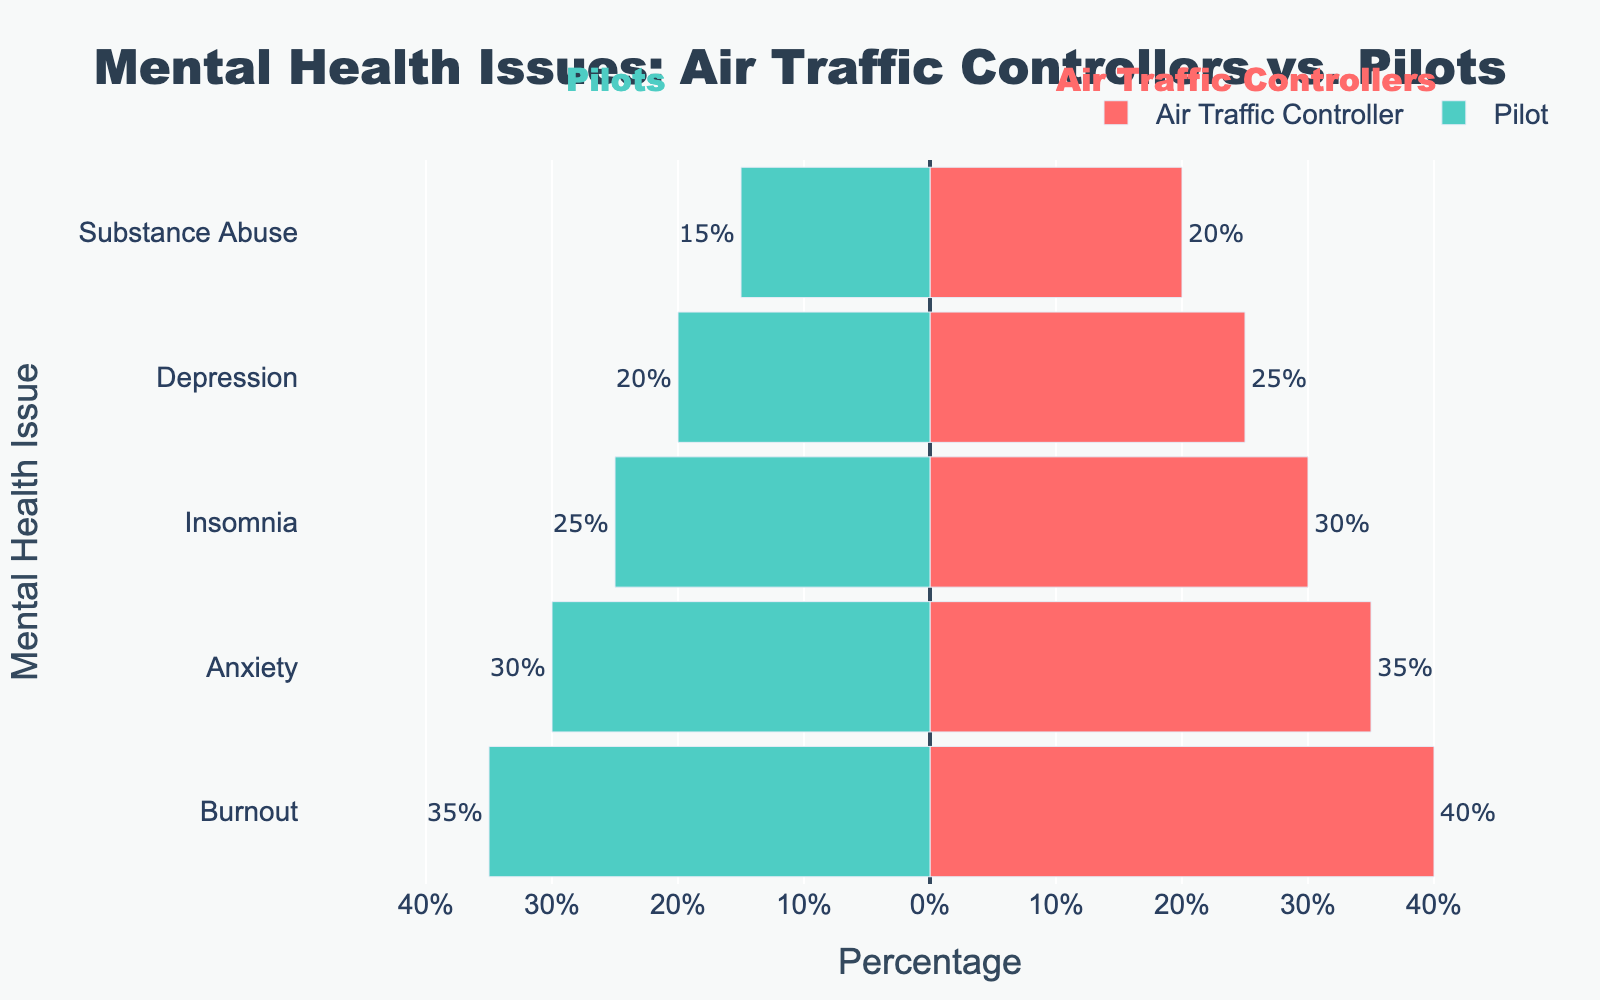Which profession has a higher percentage of anxiety issues? The bars representing anxiety indicate that Air Traffic Controllers have a 35% rate, while Pilots have a 30% rate. Therefore, Air Traffic Controllers have a higher percentage of anxiety issues.
Answer: Air Traffic Controllers What is the difference in the percentage of burnout between Air Traffic Controllers and Pilots? Air Traffic Controllers exhibit a burnout percentage of 40%, whereas Pilots have a 35% rate. Subtracting these values gives 40% - 35% = 5%.
Answer: 5% Which profession has fewer issues with substance abuse, and by what percentage? On the graph, Pilots have a 15% rate of substance abuse, while Air Traffic Controllers have a 20% rate. Subtracting these values gives 20% - 15% = 5%. Therefore, Pilots have fewer issues with substance abuse by 5%.
Answer: Pilots, 5% What is the sum of the percentages for depression and insomnia among Air Traffic Controllers? The graph shows that Air Traffic Controllers have a 25% rate for depression and a 30% rate for insomnia. Adding these values gives 25% + 30% = 55%.
Answer: 55% Which mental health issue has the largest difference in percentage between the two professions? By analyzing each mental health issue on the graph, burnout has the following percentages: Air Traffic Controllers at 40% and Pilots at 35%. This 5% difference is the largest among all the compared categories.
Answer: Burnout Among the issues affecting Air Traffic Controllers, which has the smallest percentage? By observing the lengths of the bars for Air Traffic Controllers, substance abuse has the smallest percentage at 20%.
Answer: Substance Abuse By how much does the percentage of depression in Air Traffic Controllers exceed that in Pilots? The percentage of depression among Air Traffic Controllers is 25%, and among Pilots, it’s 20%. The difference is 25% - 20% = 5%.
Answer: 5% Which profession has a closer percentage of insomnia issues to their percentage of anxiety issues? Air Traffic Controllers have an anxiety rate of 35% and an insomnia rate of 30% (difference of 5%). Pilots have an anxiety rate of 30% and an insomnia rate of 25% (difference of 5%). Both professions have the same difference, so neither profession is closer.
Answer: Neither If the combined percentage of all the issues for Pilots is X and for Air Traffic Controllers is Y, which profession has a higher combined percentage, and what is the difference? Summing the values: Pilots: 30% (Anxiety) + 20% (Depression) + 25% (Insomnia) + 35% (Burnout) + 15% (Substance Abuse) = 125%. Air Traffic Controllers: 35% (Anxiety) + 25% (Depression) + 30% (Insomnia) + 40% (Burnout) + 20% (Substance Abuse) = 150%. The difference is 150% - 125% = 25%.
Answer: Air Traffic Controllers, 25% 